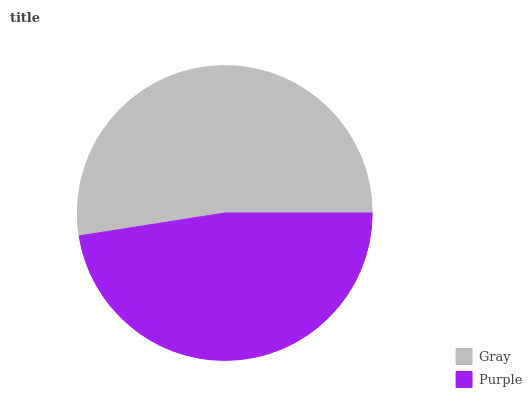Is Purple the minimum?
Answer yes or no. Yes. Is Gray the maximum?
Answer yes or no. Yes. Is Purple the maximum?
Answer yes or no. No. Is Gray greater than Purple?
Answer yes or no. Yes. Is Purple less than Gray?
Answer yes or no. Yes. Is Purple greater than Gray?
Answer yes or no. No. Is Gray less than Purple?
Answer yes or no. No. Is Gray the high median?
Answer yes or no. Yes. Is Purple the low median?
Answer yes or no. Yes. Is Purple the high median?
Answer yes or no. No. Is Gray the low median?
Answer yes or no. No. 